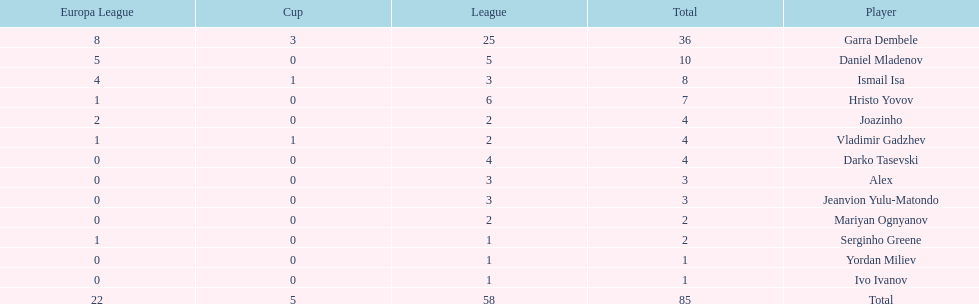What is the difference between vladimir gadzhev and yordan miliev's scores? 3. 